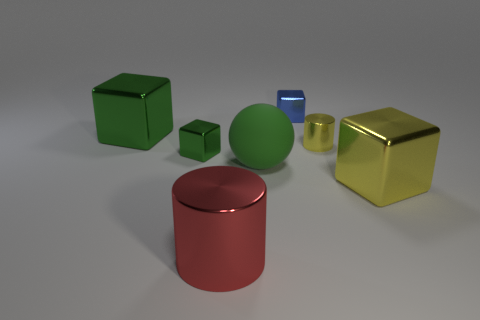Subtract all yellow cubes. How many cubes are left? 3 Subtract all blue blocks. How many blocks are left? 3 Add 3 green blocks. How many objects exist? 10 Subtract all blocks. How many objects are left? 3 Subtract all yellow spheres. How many green blocks are left? 2 Subtract all blue spheres. Subtract all cyan cubes. How many spheres are left? 1 Subtract all tiny green objects. Subtract all large gray metal cylinders. How many objects are left? 6 Add 6 red metal objects. How many red metal objects are left? 7 Add 6 green metallic cubes. How many green metallic cubes exist? 8 Subtract 0 red blocks. How many objects are left? 7 